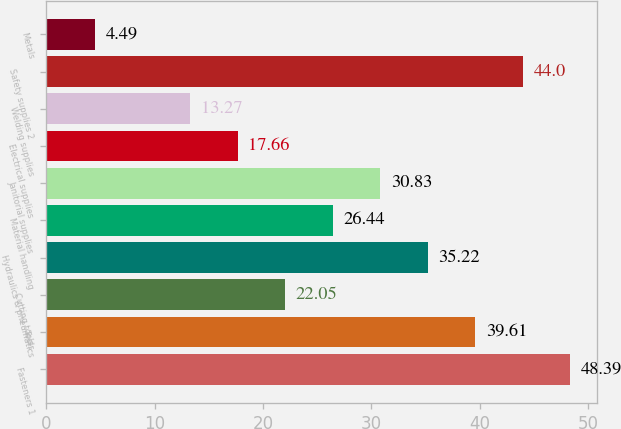Convert chart. <chart><loc_0><loc_0><loc_500><loc_500><bar_chart><fcel>Fasteners 1<fcel>Tools<fcel>Cutting tools<fcel>Hydraulics & pneumatics<fcel>Material handling<fcel>Janitorial supplies<fcel>Electrical supplies<fcel>Welding supplies<fcel>Safety supplies 2<fcel>Metals<nl><fcel>48.39<fcel>39.61<fcel>22.05<fcel>35.22<fcel>26.44<fcel>30.83<fcel>17.66<fcel>13.27<fcel>44<fcel>4.49<nl></chart> 